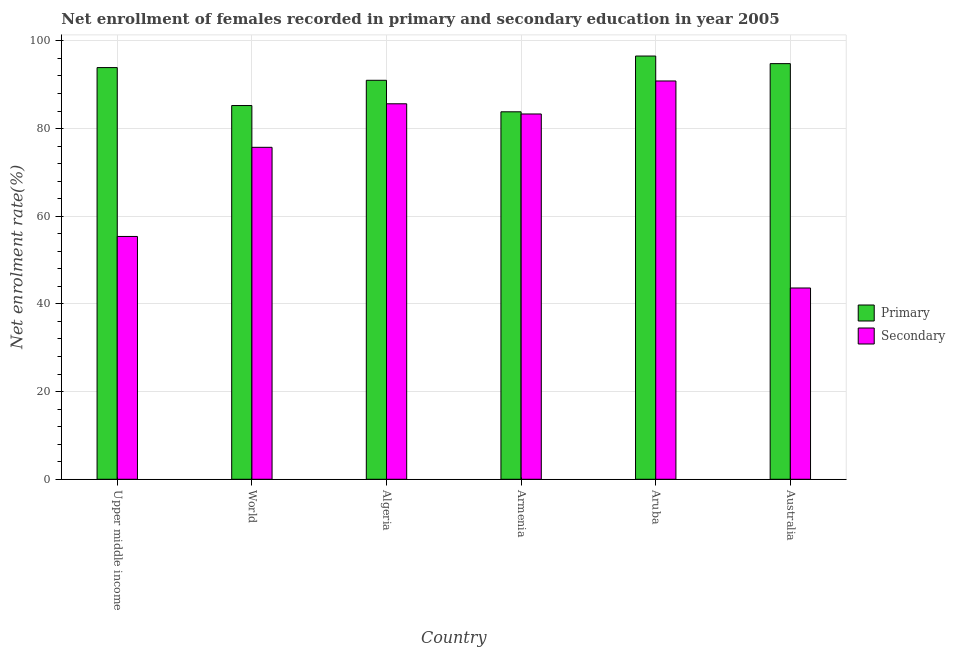How many groups of bars are there?
Provide a short and direct response. 6. Are the number of bars per tick equal to the number of legend labels?
Provide a short and direct response. Yes. How many bars are there on the 3rd tick from the left?
Your answer should be compact. 2. What is the label of the 5th group of bars from the left?
Give a very brief answer. Aruba. What is the enrollment rate in secondary education in Upper middle income?
Make the answer very short. 55.39. Across all countries, what is the maximum enrollment rate in secondary education?
Provide a succinct answer. 90.85. Across all countries, what is the minimum enrollment rate in primary education?
Your answer should be very brief. 83.82. In which country was the enrollment rate in primary education maximum?
Your answer should be compact. Aruba. What is the total enrollment rate in secondary education in the graph?
Ensure brevity in your answer.  434.56. What is the difference between the enrollment rate in secondary education in Algeria and that in World?
Ensure brevity in your answer.  9.93. What is the difference between the enrollment rate in secondary education in Upper middle income and the enrollment rate in primary education in Armenia?
Make the answer very short. -28.43. What is the average enrollment rate in secondary education per country?
Your answer should be compact. 72.43. What is the difference between the enrollment rate in primary education and enrollment rate in secondary education in Upper middle income?
Ensure brevity in your answer.  38.52. What is the ratio of the enrollment rate in secondary education in Armenia to that in World?
Ensure brevity in your answer.  1.1. Is the difference between the enrollment rate in primary education in Algeria and Armenia greater than the difference between the enrollment rate in secondary education in Algeria and Armenia?
Make the answer very short. Yes. What is the difference between the highest and the second highest enrollment rate in primary education?
Make the answer very short. 1.73. What is the difference between the highest and the lowest enrollment rate in secondary education?
Ensure brevity in your answer.  47.22. In how many countries, is the enrollment rate in primary education greater than the average enrollment rate in primary education taken over all countries?
Offer a very short reply. 4. What does the 1st bar from the left in World represents?
Provide a short and direct response. Primary. What does the 1st bar from the right in Aruba represents?
Ensure brevity in your answer.  Secondary. What is the title of the graph?
Provide a succinct answer. Net enrollment of females recorded in primary and secondary education in year 2005. Does "Short-term debt" appear as one of the legend labels in the graph?
Offer a terse response. No. What is the label or title of the X-axis?
Your answer should be very brief. Country. What is the label or title of the Y-axis?
Make the answer very short. Net enrolment rate(%). What is the Net enrolment rate(%) of Primary in Upper middle income?
Provide a short and direct response. 93.91. What is the Net enrolment rate(%) of Secondary in Upper middle income?
Offer a terse response. 55.39. What is the Net enrolment rate(%) in Primary in World?
Give a very brief answer. 85.25. What is the Net enrolment rate(%) of Secondary in World?
Give a very brief answer. 75.72. What is the Net enrolment rate(%) of Primary in Algeria?
Your answer should be compact. 91.01. What is the Net enrolment rate(%) of Secondary in Algeria?
Keep it short and to the point. 85.65. What is the Net enrolment rate(%) in Primary in Armenia?
Provide a short and direct response. 83.82. What is the Net enrolment rate(%) of Secondary in Armenia?
Give a very brief answer. 83.32. What is the Net enrolment rate(%) in Primary in Aruba?
Make the answer very short. 96.54. What is the Net enrolment rate(%) in Secondary in Aruba?
Provide a short and direct response. 90.85. What is the Net enrolment rate(%) of Primary in Australia?
Provide a short and direct response. 94.81. What is the Net enrolment rate(%) of Secondary in Australia?
Your response must be concise. 43.63. Across all countries, what is the maximum Net enrolment rate(%) in Primary?
Make the answer very short. 96.54. Across all countries, what is the maximum Net enrolment rate(%) of Secondary?
Your response must be concise. 90.85. Across all countries, what is the minimum Net enrolment rate(%) in Primary?
Your response must be concise. 83.82. Across all countries, what is the minimum Net enrolment rate(%) in Secondary?
Offer a very short reply. 43.63. What is the total Net enrolment rate(%) in Primary in the graph?
Make the answer very short. 545.34. What is the total Net enrolment rate(%) in Secondary in the graph?
Keep it short and to the point. 434.56. What is the difference between the Net enrolment rate(%) of Primary in Upper middle income and that in World?
Provide a short and direct response. 8.66. What is the difference between the Net enrolment rate(%) in Secondary in Upper middle income and that in World?
Provide a short and direct response. -20.33. What is the difference between the Net enrolment rate(%) of Primary in Upper middle income and that in Algeria?
Keep it short and to the point. 2.9. What is the difference between the Net enrolment rate(%) in Secondary in Upper middle income and that in Algeria?
Keep it short and to the point. -30.26. What is the difference between the Net enrolment rate(%) in Primary in Upper middle income and that in Armenia?
Make the answer very short. 10.09. What is the difference between the Net enrolment rate(%) of Secondary in Upper middle income and that in Armenia?
Keep it short and to the point. -27.94. What is the difference between the Net enrolment rate(%) in Primary in Upper middle income and that in Aruba?
Offer a terse response. -2.63. What is the difference between the Net enrolment rate(%) in Secondary in Upper middle income and that in Aruba?
Ensure brevity in your answer.  -35.46. What is the difference between the Net enrolment rate(%) in Primary in Upper middle income and that in Australia?
Your answer should be compact. -0.9. What is the difference between the Net enrolment rate(%) of Secondary in Upper middle income and that in Australia?
Keep it short and to the point. 11.76. What is the difference between the Net enrolment rate(%) of Primary in World and that in Algeria?
Give a very brief answer. -5.76. What is the difference between the Net enrolment rate(%) of Secondary in World and that in Algeria?
Your answer should be compact. -9.93. What is the difference between the Net enrolment rate(%) in Primary in World and that in Armenia?
Give a very brief answer. 1.43. What is the difference between the Net enrolment rate(%) of Secondary in World and that in Armenia?
Ensure brevity in your answer.  -7.61. What is the difference between the Net enrolment rate(%) of Primary in World and that in Aruba?
Make the answer very short. -11.29. What is the difference between the Net enrolment rate(%) of Secondary in World and that in Aruba?
Make the answer very short. -15.13. What is the difference between the Net enrolment rate(%) in Primary in World and that in Australia?
Offer a terse response. -9.56. What is the difference between the Net enrolment rate(%) in Secondary in World and that in Australia?
Provide a succinct answer. 32.09. What is the difference between the Net enrolment rate(%) of Primary in Algeria and that in Armenia?
Your answer should be very brief. 7.19. What is the difference between the Net enrolment rate(%) in Secondary in Algeria and that in Armenia?
Keep it short and to the point. 2.32. What is the difference between the Net enrolment rate(%) in Primary in Algeria and that in Aruba?
Your response must be concise. -5.53. What is the difference between the Net enrolment rate(%) in Secondary in Algeria and that in Aruba?
Give a very brief answer. -5.2. What is the difference between the Net enrolment rate(%) of Primary in Algeria and that in Australia?
Keep it short and to the point. -3.8. What is the difference between the Net enrolment rate(%) in Secondary in Algeria and that in Australia?
Ensure brevity in your answer.  42.02. What is the difference between the Net enrolment rate(%) in Primary in Armenia and that in Aruba?
Provide a short and direct response. -12.72. What is the difference between the Net enrolment rate(%) of Secondary in Armenia and that in Aruba?
Make the answer very short. -7.53. What is the difference between the Net enrolment rate(%) in Primary in Armenia and that in Australia?
Your answer should be compact. -10.99. What is the difference between the Net enrolment rate(%) of Secondary in Armenia and that in Australia?
Offer a very short reply. 39.69. What is the difference between the Net enrolment rate(%) of Primary in Aruba and that in Australia?
Offer a very short reply. 1.73. What is the difference between the Net enrolment rate(%) of Secondary in Aruba and that in Australia?
Make the answer very short. 47.22. What is the difference between the Net enrolment rate(%) of Primary in Upper middle income and the Net enrolment rate(%) of Secondary in World?
Offer a terse response. 18.19. What is the difference between the Net enrolment rate(%) in Primary in Upper middle income and the Net enrolment rate(%) in Secondary in Algeria?
Your response must be concise. 8.26. What is the difference between the Net enrolment rate(%) of Primary in Upper middle income and the Net enrolment rate(%) of Secondary in Armenia?
Give a very brief answer. 10.58. What is the difference between the Net enrolment rate(%) of Primary in Upper middle income and the Net enrolment rate(%) of Secondary in Aruba?
Keep it short and to the point. 3.06. What is the difference between the Net enrolment rate(%) in Primary in Upper middle income and the Net enrolment rate(%) in Secondary in Australia?
Your answer should be very brief. 50.28. What is the difference between the Net enrolment rate(%) in Primary in World and the Net enrolment rate(%) in Secondary in Algeria?
Give a very brief answer. -0.4. What is the difference between the Net enrolment rate(%) of Primary in World and the Net enrolment rate(%) of Secondary in Armenia?
Keep it short and to the point. 1.93. What is the difference between the Net enrolment rate(%) of Primary in World and the Net enrolment rate(%) of Secondary in Aruba?
Provide a succinct answer. -5.6. What is the difference between the Net enrolment rate(%) of Primary in World and the Net enrolment rate(%) of Secondary in Australia?
Ensure brevity in your answer.  41.62. What is the difference between the Net enrolment rate(%) in Primary in Algeria and the Net enrolment rate(%) in Secondary in Armenia?
Give a very brief answer. 7.69. What is the difference between the Net enrolment rate(%) of Primary in Algeria and the Net enrolment rate(%) of Secondary in Aruba?
Your answer should be very brief. 0.16. What is the difference between the Net enrolment rate(%) of Primary in Algeria and the Net enrolment rate(%) of Secondary in Australia?
Offer a terse response. 47.38. What is the difference between the Net enrolment rate(%) of Primary in Armenia and the Net enrolment rate(%) of Secondary in Aruba?
Your answer should be very brief. -7.03. What is the difference between the Net enrolment rate(%) of Primary in Armenia and the Net enrolment rate(%) of Secondary in Australia?
Keep it short and to the point. 40.19. What is the difference between the Net enrolment rate(%) of Primary in Aruba and the Net enrolment rate(%) of Secondary in Australia?
Provide a short and direct response. 52.91. What is the average Net enrolment rate(%) of Primary per country?
Provide a short and direct response. 90.89. What is the average Net enrolment rate(%) of Secondary per country?
Keep it short and to the point. 72.43. What is the difference between the Net enrolment rate(%) of Primary and Net enrolment rate(%) of Secondary in Upper middle income?
Make the answer very short. 38.52. What is the difference between the Net enrolment rate(%) in Primary and Net enrolment rate(%) in Secondary in World?
Your response must be concise. 9.53. What is the difference between the Net enrolment rate(%) in Primary and Net enrolment rate(%) in Secondary in Algeria?
Your answer should be very brief. 5.36. What is the difference between the Net enrolment rate(%) of Primary and Net enrolment rate(%) of Secondary in Armenia?
Your response must be concise. 0.5. What is the difference between the Net enrolment rate(%) of Primary and Net enrolment rate(%) of Secondary in Aruba?
Offer a terse response. 5.69. What is the difference between the Net enrolment rate(%) of Primary and Net enrolment rate(%) of Secondary in Australia?
Provide a succinct answer. 51.18. What is the ratio of the Net enrolment rate(%) in Primary in Upper middle income to that in World?
Your answer should be compact. 1.1. What is the ratio of the Net enrolment rate(%) in Secondary in Upper middle income to that in World?
Your response must be concise. 0.73. What is the ratio of the Net enrolment rate(%) in Primary in Upper middle income to that in Algeria?
Keep it short and to the point. 1.03. What is the ratio of the Net enrolment rate(%) in Secondary in Upper middle income to that in Algeria?
Ensure brevity in your answer.  0.65. What is the ratio of the Net enrolment rate(%) in Primary in Upper middle income to that in Armenia?
Provide a succinct answer. 1.12. What is the ratio of the Net enrolment rate(%) in Secondary in Upper middle income to that in Armenia?
Your answer should be compact. 0.66. What is the ratio of the Net enrolment rate(%) in Primary in Upper middle income to that in Aruba?
Your answer should be compact. 0.97. What is the ratio of the Net enrolment rate(%) in Secondary in Upper middle income to that in Aruba?
Offer a terse response. 0.61. What is the ratio of the Net enrolment rate(%) in Primary in Upper middle income to that in Australia?
Your answer should be very brief. 0.99. What is the ratio of the Net enrolment rate(%) of Secondary in Upper middle income to that in Australia?
Provide a succinct answer. 1.27. What is the ratio of the Net enrolment rate(%) of Primary in World to that in Algeria?
Give a very brief answer. 0.94. What is the ratio of the Net enrolment rate(%) of Secondary in World to that in Algeria?
Ensure brevity in your answer.  0.88. What is the ratio of the Net enrolment rate(%) in Secondary in World to that in Armenia?
Keep it short and to the point. 0.91. What is the ratio of the Net enrolment rate(%) of Primary in World to that in Aruba?
Keep it short and to the point. 0.88. What is the ratio of the Net enrolment rate(%) in Secondary in World to that in Aruba?
Keep it short and to the point. 0.83. What is the ratio of the Net enrolment rate(%) in Primary in World to that in Australia?
Ensure brevity in your answer.  0.9. What is the ratio of the Net enrolment rate(%) of Secondary in World to that in Australia?
Ensure brevity in your answer.  1.74. What is the ratio of the Net enrolment rate(%) in Primary in Algeria to that in Armenia?
Keep it short and to the point. 1.09. What is the ratio of the Net enrolment rate(%) in Secondary in Algeria to that in Armenia?
Make the answer very short. 1.03. What is the ratio of the Net enrolment rate(%) in Primary in Algeria to that in Aruba?
Give a very brief answer. 0.94. What is the ratio of the Net enrolment rate(%) in Secondary in Algeria to that in Aruba?
Provide a short and direct response. 0.94. What is the ratio of the Net enrolment rate(%) of Primary in Algeria to that in Australia?
Your answer should be compact. 0.96. What is the ratio of the Net enrolment rate(%) of Secondary in Algeria to that in Australia?
Your answer should be compact. 1.96. What is the ratio of the Net enrolment rate(%) of Primary in Armenia to that in Aruba?
Offer a very short reply. 0.87. What is the ratio of the Net enrolment rate(%) of Secondary in Armenia to that in Aruba?
Give a very brief answer. 0.92. What is the ratio of the Net enrolment rate(%) of Primary in Armenia to that in Australia?
Offer a terse response. 0.88. What is the ratio of the Net enrolment rate(%) in Secondary in Armenia to that in Australia?
Make the answer very short. 1.91. What is the ratio of the Net enrolment rate(%) of Primary in Aruba to that in Australia?
Your answer should be very brief. 1.02. What is the ratio of the Net enrolment rate(%) of Secondary in Aruba to that in Australia?
Your response must be concise. 2.08. What is the difference between the highest and the second highest Net enrolment rate(%) in Primary?
Offer a very short reply. 1.73. What is the difference between the highest and the second highest Net enrolment rate(%) of Secondary?
Give a very brief answer. 5.2. What is the difference between the highest and the lowest Net enrolment rate(%) of Primary?
Provide a succinct answer. 12.72. What is the difference between the highest and the lowest Net enrolment rate(%) in Secondary?
Provide a succinct answer. 47.22. 